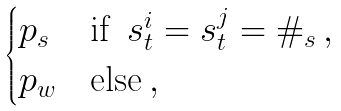Convert formula to latex. <formula><loc_0><loc_0><loc_500><loc_500>\begin{cases} p _ { s } & \text {if } \, s ^ { i } _ { t } = s ^ { j } _ { t } = \# _ { s } \, , \\ p _ { w } & \text {else} \, , \\ \end{cases}</formula> 